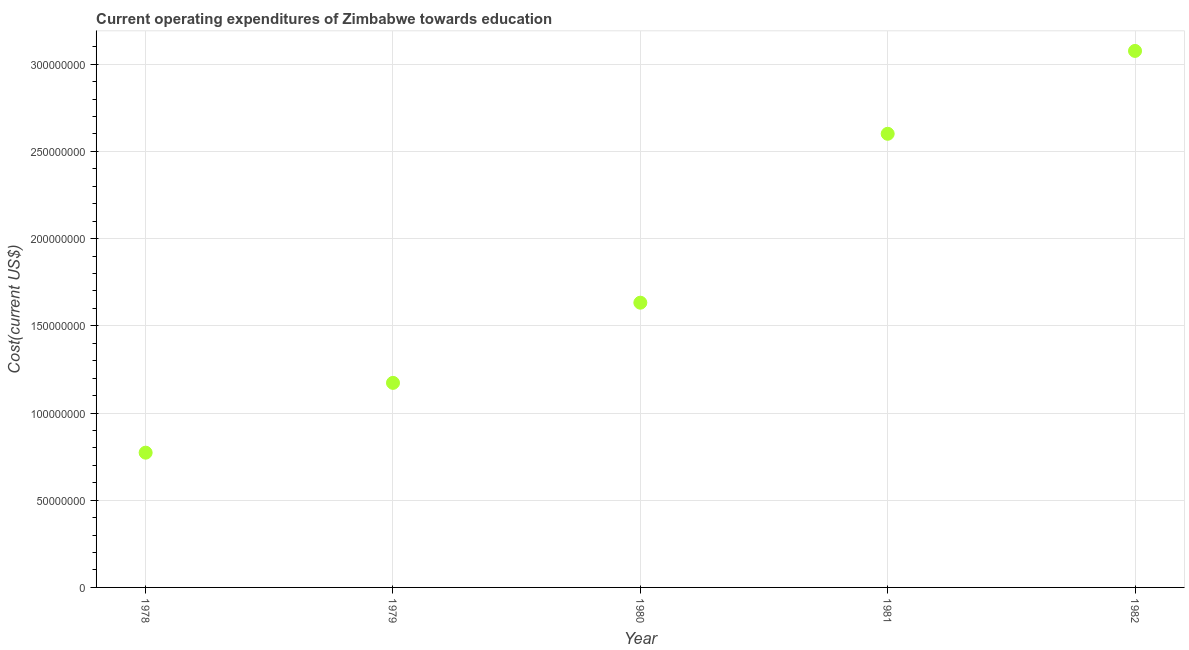What is the education expenditure in 1981?
Offer a very short reply. 2.60e+08. Across all years, what is the maximum education expenditure?
Keep it short and to the point. 3.08e+08. Across all years, what is the minimum education expenditure?
Your answer should be compact. 7.73e+07. In which year was the education expenditure maximum?
Provide a short and direct response. 1982. In which year was the education expenditure minimum?
Offer a very short reply. 1978. What is the sum of the education expenditure?
Offer a very short reply. 9.25e+08. What is the difference between the education expenditure in 1978 and 1981?
Your answer should be compact. -1.83e+08. What is the average education expenditure per year?
Make the answer very short. 1.85e+08. What is the median education expenditure?
Provide a succinct answer. 1.63e+08. In how many years, is the education expenditure greater than 150000000 US$?
Provide a short and direct response. 3. Do a majority of the years between 1981 and 1978 (inclusive) have education expenditure greater than 110000000 US$?
Make the answer very short. Yes. What is the ratio of the education expenditure in 1980 to that in 1981?
Provide a short and direct response. 0.63. Is the education expenditure in 1978 less than that in 1979?
Ensure brevity in your answer.  Yes. What is the difference between the highest and the second highest education expenditure?
Your response must be concise. 4.75e+07. Is the sum of the education expenditure in 1980 and 1982 greater than the maximum education expenditure across all years?
Give a very brief answer. Yes. What is the difference between the highest and the lowest education expenditure?
Offer a very short reply. 2.30e+08. In how many years, is the education expenditure greater than the average education expenditure taken over all years?
Provide a short and direct response. 2. Does the education expenditure monotonically increase over the years?
Ensure brevity in your answer.  Yes. What is the difference between two consecutive major ticks on the Y-axis?
Your answer should be compact. 5.00e+07. Does the graph contain any zero values?
Make the answer very short. No. What is the title of the graph?
Provide a succinct answer. Current operating expenditures of Zimbabwe towards education. What is the label or title of the X-axis?
Offer a terse response. Year. What is the label or title of the Y-axis?
Provide a short and direct response. Cost(current US$). What is the Cost(current US$) in 1978?
Make the answer very short. 7.73e+07. What is the Cost(current US$) in 1979?
Your answer should be very brief. 1.17e+08. What is the Cost(current US$) in 1980?
Your answer should be compact. 1.63e+08. What is the Cost(current US$) in 1981?
Offer a terse response. 2.60e+08. What is the Cost(current US$) in 1982?
Your response must be concise. 3.08e+08. What is the difference between the Cost(current US$) in 1978 and 1979?
Your answer should be compact. -4.00e+07. What is the difference between the Cost(current US$) in 1978 and 1980?
Offer a terse response. -8.60e+07. What is the difference between the Cost(current US$) in 1978 and 1981?
Provide a short and direct response. -1.83e+08. What is the difference between the Cost(current US$) in 1978 and 1982?
Provide a short and direct response. -2.30e+08. What is the difference between the Cost(current US$) in 1979 and 1980?
Offer a very short reply. -4.60e+07. What is the difference between the Cost(current US$) in 1979 and 1981?
Ensure brevity in your answer.  -1.43e+08. What is the difference between the Cost(current US$) in 1979 and 1982?
Your answer should be compact. -1.90e+08. What is the difference between the Cost(current US$) in 1980 and 1981?
Keep it short and to the point. -9.68e+07. What is the difference between the Cost(current US$) in 1980 and 1982?
Offer a very short reply. -1.44e+08. What is the difference between the Cost(current US$) in 1981 and 1982?
Offer a terse response. -4.75e+07. What is the ratio of the Cost(current US$) in 1978 to that in 1979?
Provide a succinct answer. 0.66. What is the ratio of the Cost(current US$) in 1978 to that in 1980?
Make the answer very short. 0.47. What is the ratio of the Cost(current US$) in 1978 to that in 1981?
Provide a short and direct response. 0.3. What is the ratio of the Cost(current US$) in 1978 to that in 1982?
Your answer should be compact. 0.25. What is the ratio of the Cost(current US$) in 1979 to that in 1980?
Provide a succinct answer. 0.72. What is the ratio of the Cost(current US$) in 1979 to that in 1981?
Give a very brief answer. 0.45. What is the ratio of the Cost(current US$) in 1979 to that in 1982?
Keep it short and to the point. 0.38. What is the ratio of the Cost(current US$) in 1980 to that in 1981?
Ensure brevity in your answer.  0.63. What is the ratio of the Cost(current US$) in 1980 to that in 1982?
Provide a succinct answer. 0.53. What is the ratio of the Cost(current US$) in 1981 to that in 1982?
Keep it short and to the point. 0.85. 